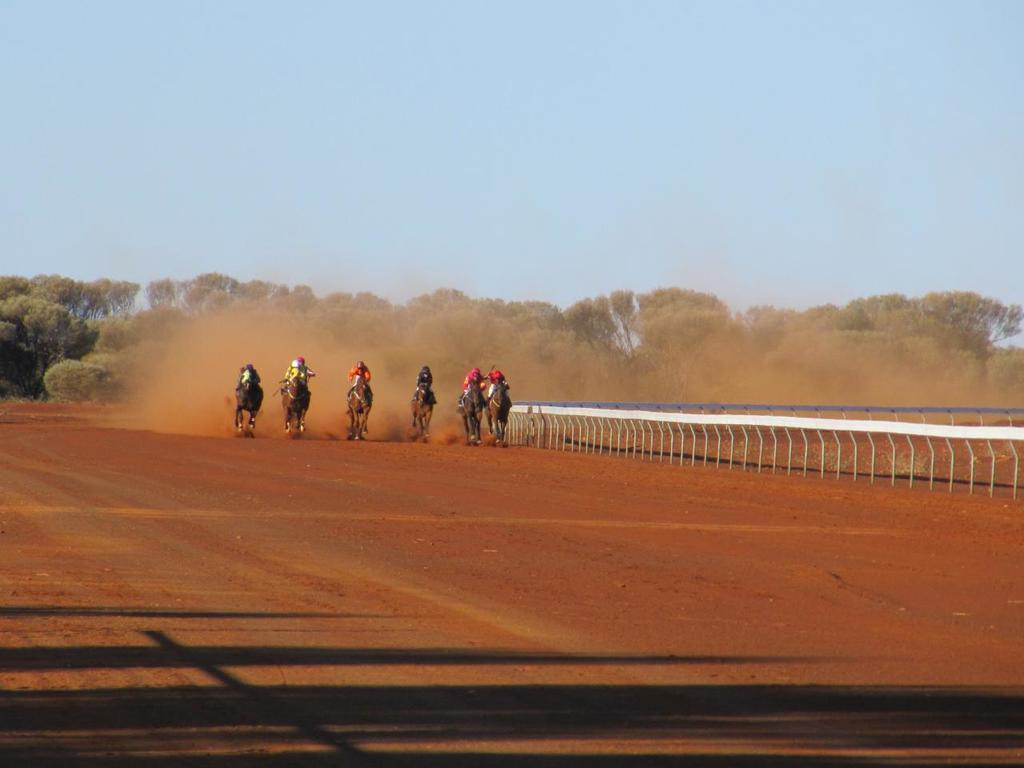What are the people in the image doing? The people in the image are riding horses. What is the surface on which the horses are standing? The horses are on a ground. What can be seen beside the group of people? There is fencing beside the group of people. What type of environment is visible in the background of the image? There are many trees in the background of the image. What type of bottle can be seen in the hands of the people riding horses? There is no bottle visible in the hands of the people riding horses in the image. Is there a flame visible in the image? No, there is no flame present in the image. 